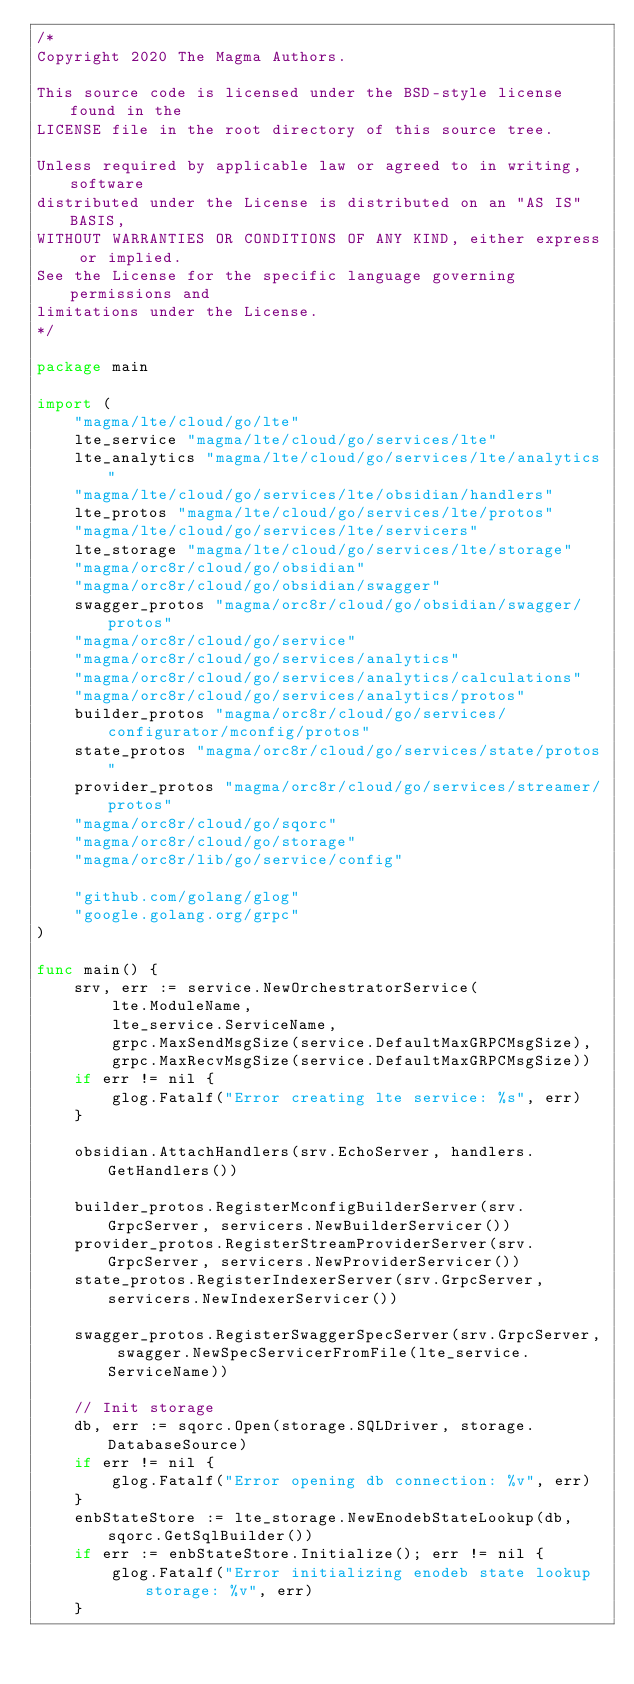<code> <loc_0><loc_0><loc_500><loc_500><_Go_>/*
Copyright 2020 The Magma Authors.

This source code is licensed under the BSD-style license found in the
LICENSE file in the root directory of this source tree.

Unless required by applicable law or agreed to in writing, software
distributed under the License is distributed on an "AS IS" BASIS,
WITHOUT WARRANTIES OR CONDITIONS OF ANY KIND, either express or implied.
See the License for the specific language governing permissions and
limitations under the License.
*/

package main

import (
	"magma/lte/cloud/go/lte"
	lte_service "magma/lte/cloud/go/services/lte"
	lte_analytics "magma/lte/cloud/go/services/lte/analytics"
	"magma/lte/cloud/go/services/lte/obsidian/handlers"
	lte_protos "magma/lte/cloud/go/services/lte/protos"
	"magma/lte/cloud/go/services/lte/servicers"
	lte_storage "magma/lte/cloud/go/services/lte/storage"
	"magma/orc8r/cloud/go/obsidian"
	"magma/orc8r/cloud/go/obsidian/swagger"
	swagger_protos "magma/orc8r/cloud/go/obsidian/swagger/protos"
	"magma/orc8r/cloud/go/service"
	"magma/orc8r/cloud/go/services/analytics"
	"magma/orc8r/cloud/go/services/analytics/calculations"
	"magma/orc8r/cloud/go/services/analytics/protos"
	builder_protos "magma/orc8r/cloud/go/services/configurator/mconfig/protos"
	state_protos "magma/orc8r/cloud/go/services/state/protos"
	provider_protos "magma/orc8r/cloud/go/services/streamer/protos"
	"magma/orc8r/cloud/go/sqorc"
	"magma/orc8r/cloud/go/storage"
	"magma/orc8r/lib/go/service/config"

	"github.com/golang/glog"
	"google.golang.org/grpc"
)

func main() {
	srv, err := service.NewOrchestratorService(
		lte.ModuleName,
		lte_service.ServiceName,
		grpc.MaxSendMsgSize(service.DefaultMaxGRPCMsgSize),
		grpc.MaxRecvMsgSize(service.DefaultMaxGRPCMsgSize))
	if err != nil {
		glog.Fatalf("Error creating lte service: %s", err)
	}

	obsidian.AttachHandlers(srv.EchoServer, handlers.GetHandlers())

	builder_protos.RegisterMconfigBuilderServer(srv.GrpcServer, servicers.NewBuilderServicer())
	provider_protos.RegisterStreamProviderServer(srv.GrpcServer, servicers.NewProviderServicer())
	state_protos.RegisterIndexerServer(srv.GrpcServer, servicers.NewIndexerServicer())

	swagger_protos.RegisterSwaggerSpecServer(srv.GrpcServer, swagger.NewSpecServicerFromFile(lte_service.ServiceName))

	// Init storage
	db, err := sqorc.Open(storage.SQLDriver, storage.DatabaseSource)
	if err != nil {
		glog.Fatalf("Error opening db connection: %v", err)
	}
	enbStateStore := lte_storage.NewEnodebStateLookup(db, sqorc.GetSqlBuilder())
	if err := enbStateStore.Initialize(); err != nil {
		glog.Fatalf("Error initializing enodeb state lookup storage: %v", err)
	}</code> 